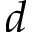Convert formula to latex. <formula><loc_0><loc_0><loc_500><loc_500>d</formula> 